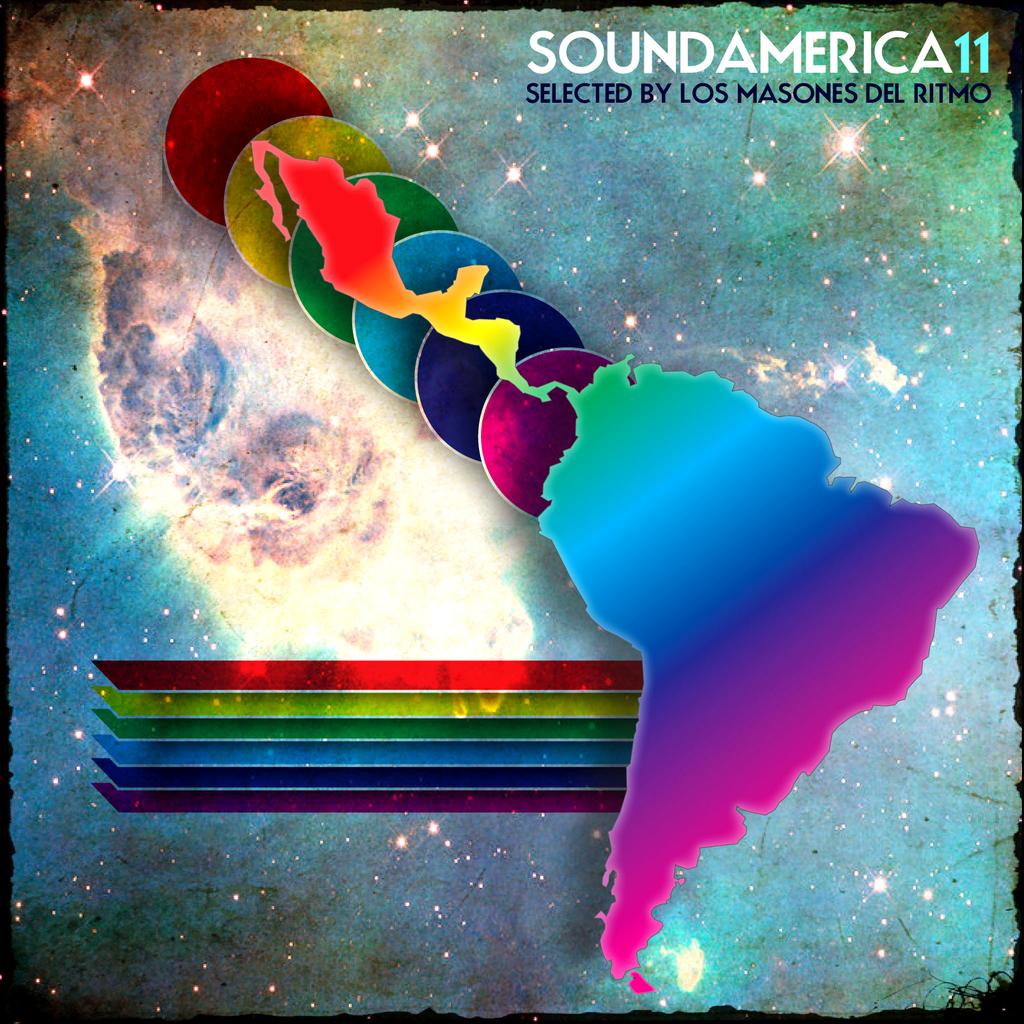Who was this selected by?
Your answer should be compact. Los masones del ritmo. What is the name of this event?
Make the answer very short. Soundamerica11. 